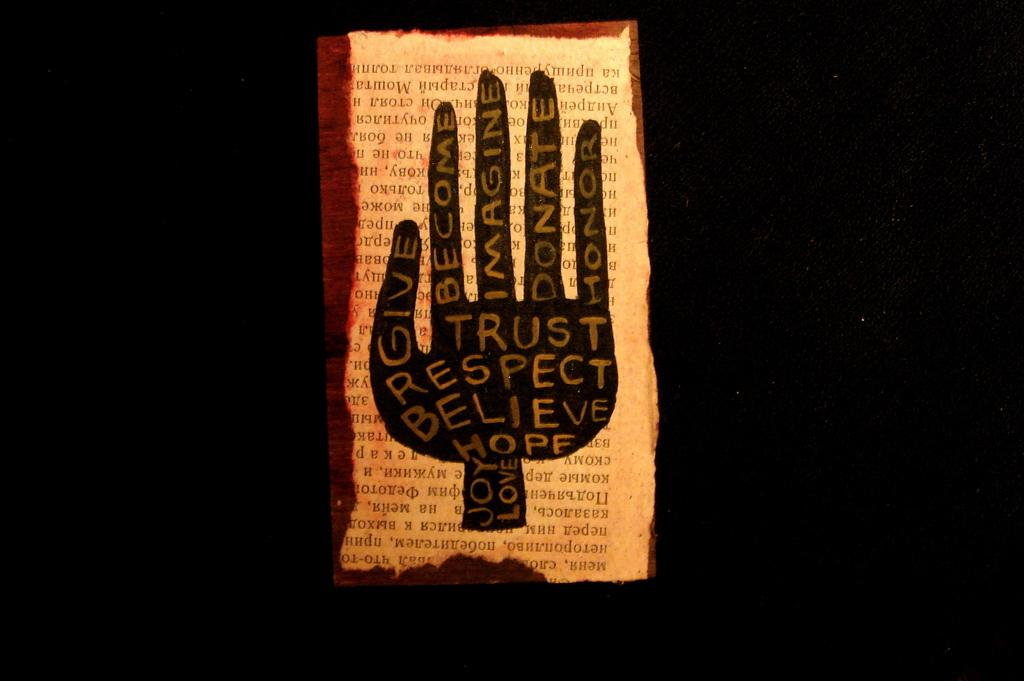<image>
Present a compact description of the photo's key features. black screen with a page with picture of hand on it with words trust, respect, believe, hope and others 